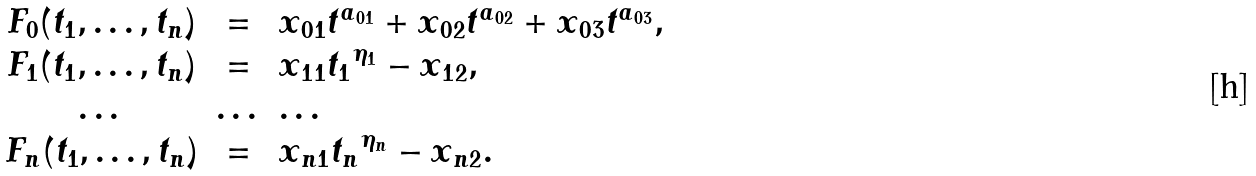<formula> <loc_0><loc_0><loc_500><loc_500>\begin{array} { c c l } F _ { 0 } ( t _ { 1 } , \dots , t _ { n } ) & = & x _ { 0 1 } { t } ^ { a _ { 0 1 } } + x _ { 0 2 } { t } ^ { a _ { 0 2 } } + x _ { 0 3 } { t } ^ { a _ { 0 3 } } , \\ F _ { 1 } ( t _ { 1 } , \dots , t _ { n } ) & = & x _ { 1 1 } { t _ { 1 } } ^ { \eta _ { 1 } } - x _ { 1 2 } , \\ \dots & \dots & \dots \\ F _ { n } ( t _ { 1 } , \dots , t _ { n } ) & = & x _ { n 1 } { t _ { n } } ^ { \eta _ { n } } - x _ { n 2 } . \end{array}</formula> 